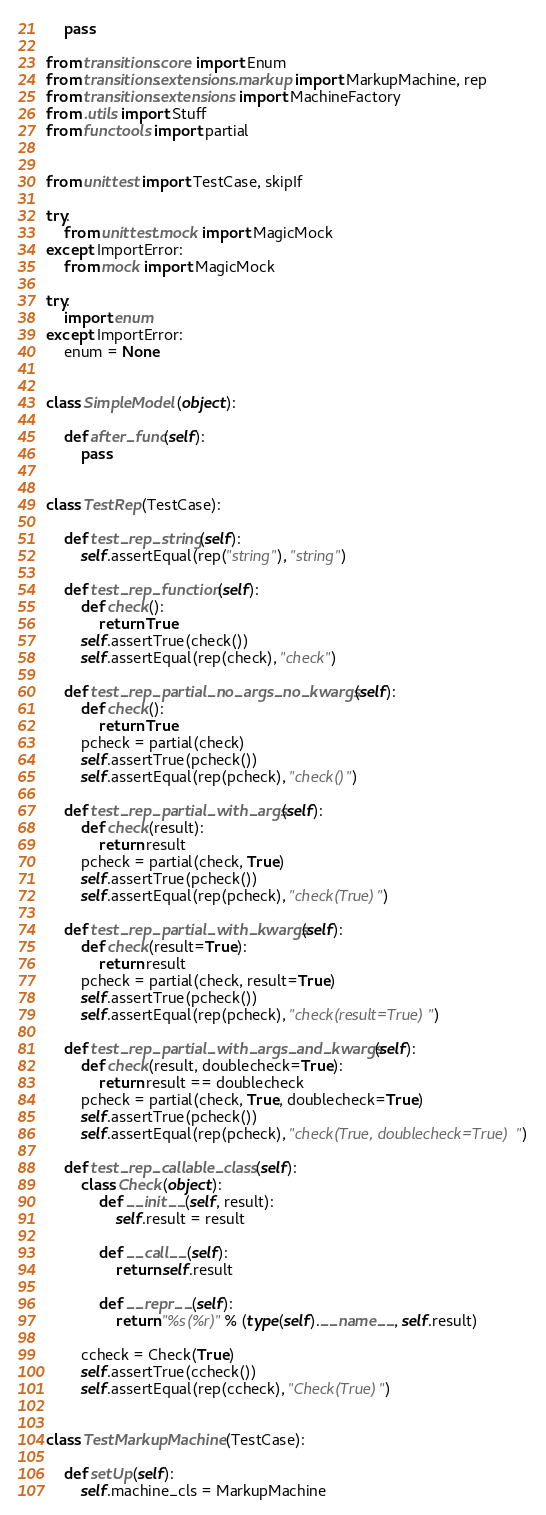Convert code to text. <code><loc_0><loc_0><loc_500><loc_500><_Python_>    pass

from transitions.core import Enum
from transitions.extensions.markup import MarkupMachine, rep
from transitions.extensions import MachineFactory
from .utils import Stuff
from functools import partial


from unittest import TestCase, skipIf

try:
    from unittest.mock import MagicMock
except ImportError:
    from mock import MagicMock

try:
    import enum
except ImportError:
    enum = None


class SimpleModel(object):

    def after_func(self):
        pass


class TestRep(TestCase):

    def test_rep_string(self):
        self.assertEqual(rep("string"), "string")

    def test_rep_function(self):
        def check():
            return True
        self.assertTrue(check())
        self.assertEqual(rep(check), "check")

    def test_rep_partial_no_args_no_kwargs(self):
        def check():
            return True
        pcheck = partial(check)
        self.assertTrue(pcheck())
        self.assertEqual(rep(pcheck), "check()")

    def test_rep_partial_with_args(self):
        def check(result):
            return result
        pcheck = partial(check, True)
        self.assertTrue(pcheck())
        self.assertEqual(rep(pcheck), "check(True)")

    def test_rep_partial_with_kwargs(self):
        def check(result=True):
            return result
        pcheck = partial(check, result=True)
        self.assertTrue(pcheck())
        self.assertEqual(rep(pcheck), "check(result=True)")

    def test_rep_partial_with_args_and_kwargs(self):
        def check(result, doublecheck=True):
            return result == doublecheck
        pcheck = partial(check, True, doublecheck=True)
        self.assertTrue(pcheck())
        self.assertEqual(rep(pcheck), "check(True, doublecheck=True)")

    def test_rep_callable_class(self):
        class Check(object):
            def __init__(self, result):
                self.result = result

            def __call__(self):
                return self.result

            def __repr__(self):
                return "%s(%r)" % (type(self).__name__, self.result)

        ccheck = Check(True)
        self.assertTrue(ccheck())
        self.assertEqual(rep(ccheck), "Check(True)")


class TestMarkupMachine(TestCase):

    def setUp(self):
        self.machine_cls = MarkupMachine</code> 